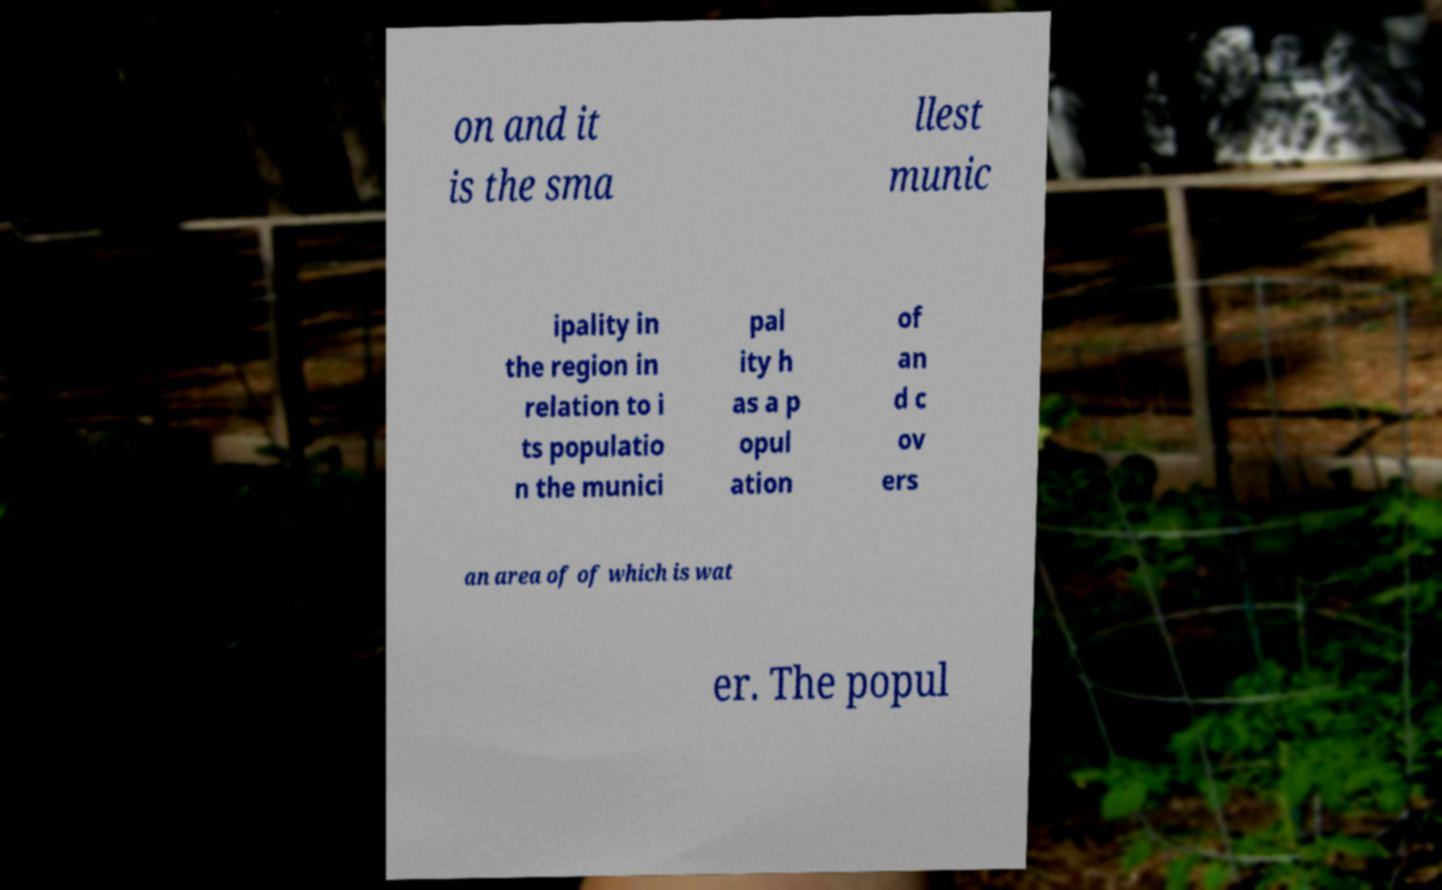Could you assist in decoding the text presented in this image and type it out clearly? on and it is the sma llest munic ipality in the region in relation to i ts populatio n the munici pal ity h as a p opul ation of an d c ov ers an area of of which is wat er. The popul 